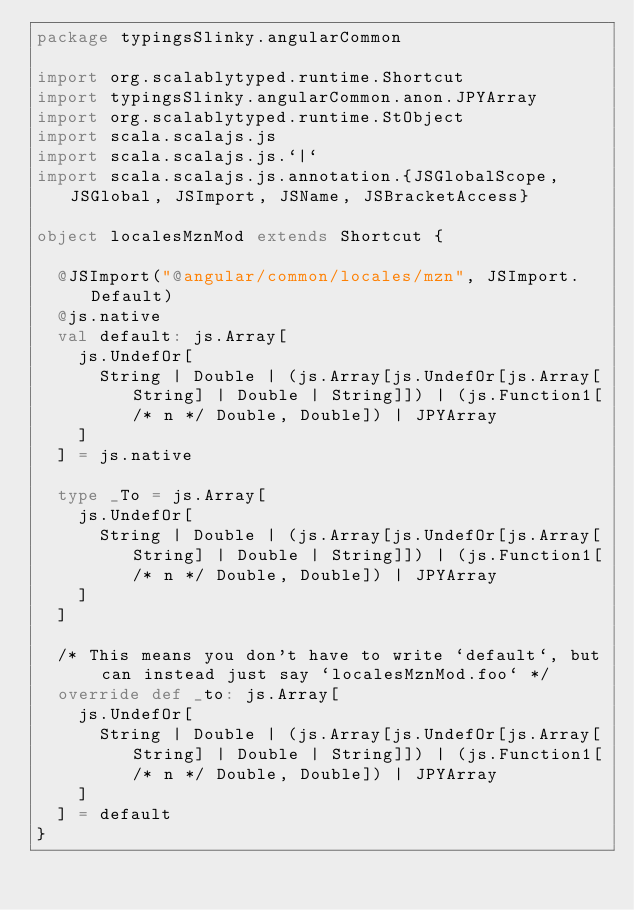Convert code to text. <code><loc_0><loc_0><loc_500><loc_500><_Scala_>package typingsSlinky.angularCommon

import org.scalablytyped.runtime.Shortcut
import typingsSlinky.angularCommon.anon.JPYArray
import org.scalablytyped.runtime.StObject
import scala.scalajs.js
import scala.scalajs.js.`|`
import scala.scalajs.js.annotation.{JSGlobalScope, JSGlobal, JSImport, JSName, JSBracketAccess}

object localesMznMod extends Shortcut {
  
  @JSImport("@angular/common/locales/mzn", JSImport.Default)
  @js.native
  val default: js.Array[
    js.UndefOr[
      String | Double | (js.Array[js.UndefOr[js.Array[String] | Double | String]]) | (js.Function1[/* n */ Double, Double]) | JPYArray
    ]
  ] = js.native
  
  type _To = js.Array[
    js.UndefOr[
      String | Double | (js.Array[js.UndefOr[js.Array[String] | Double | String]]) | (js.Function1[/* n */ Double, Double]) | JPYArray
    ]
  ]
  
  /* This means you don't have to write `default`, but can instead just say `localesMznMod.foo` */
  override def _to: js.Array[
    js.UndefOr[
      String | Double | (js.Array[js.UndefOr[js.Array[String] | Double | String]]) | (js.Function1[/* n */ Double, Double]) | JPYArray
    ]
  ] = default
}
</code> 